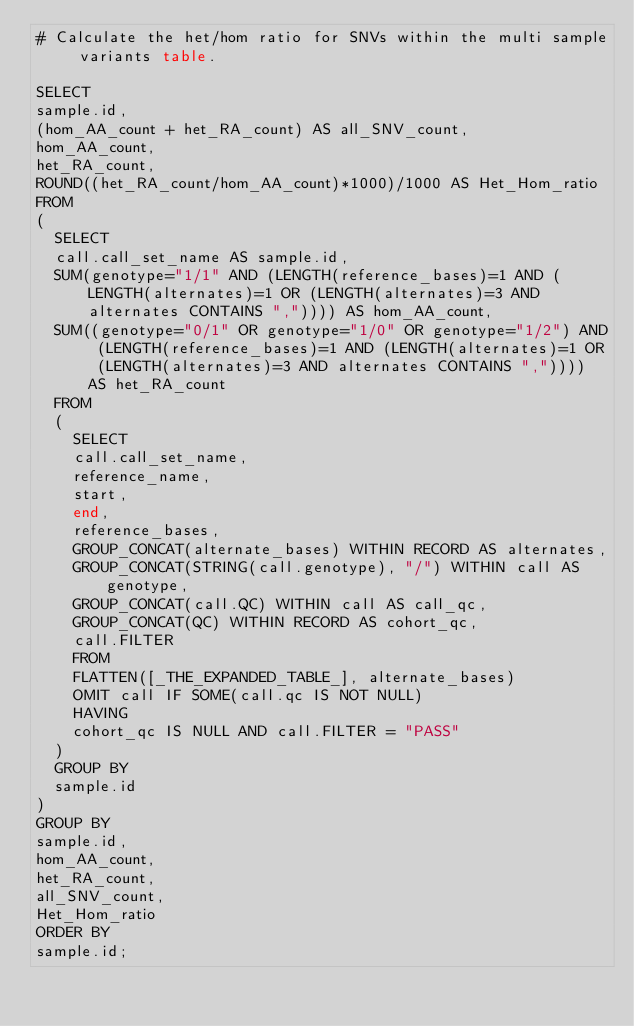Convert code to text. <code><loc_0><loc_0><loc_500><loc_500><_SQL_># Calculate the het/hom ratio for SNVs within the multi sample variants table.

SELECT
sample.id,
(hom_AA_count + het_RA_count) AS all_SNV_count,
hom_AA_count,
het_RA_count,
ROUND((het_RA_count/hom_AA_count)*1000)/1000 AS Het_Hom_ratio
FROM
(
  SELECT
  call.call_set_name AS sample.id,
  SUM(genotype="1/1" AND (LENGTH(reference_bases)=1 AND (LENGTH(alternates)=1 OR (LENGTH(alternates)=3 AND alternates CONTAINS ",")))) AS hom_AA_count,
  SUM((genotype="0/1" OR genotype="1/0" OR genotype="1/2") AND (LENGTH(reference_bases)=1 AND (LENGTH(alternates)=1 OR (LENGTH(alternates)=3 AND alternates CONTAINS ",")))) AS het_RA_count    
  FROM
  (
    SELECT
    call.call_set_name,
    reference_name,
    start,
    end,
    reference_bases,
    GROUP_CONCAT(alternate_bases) WITHIN RECORD AS alternates,
    GROUP_CONCAT(STRING(call.genotype), "/") WITHIN call AS genotype,
    GROUP_CONCAT(call.QC) WITHIN call AS call_qc,
    GROUP_CONCAT(QC) WITHIN RECORD AS cohort_qc,
    call.FILTER
    FROM 
    FLATTEN([_THE_EXPANDED_TABLE_], alternate_bases)
    OMIT call IF SOME(call.qc IS NOT NULL)
    HAVING
    cohort_qc IS NULL AND call.FILTER = "PASS"
  ) 
  GROUP BY
  sample.id
)
GROUP BY
sample.id,
hom_AA_count,
het_RA_count,
all_SNV_count,
Het_Hom_ratio
ORDER BY
sample.id;
</code> 